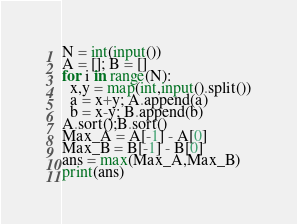Convert code to text. <code><loc_0><loc_0><loc_500><loc_500><_Python_>N = int(input())
A = []; B = []
for i in range(N):
  x,y = map(int,input().split())
  a = x+y; A.append(a)
  b = x-y; B.append(b)
A.sort();B.sort()
Max_A = A[-1] - A[0]
Max_B = B[-1] - B[0]
ans = max(Max_A,Max_B)
print(ans)</code> 